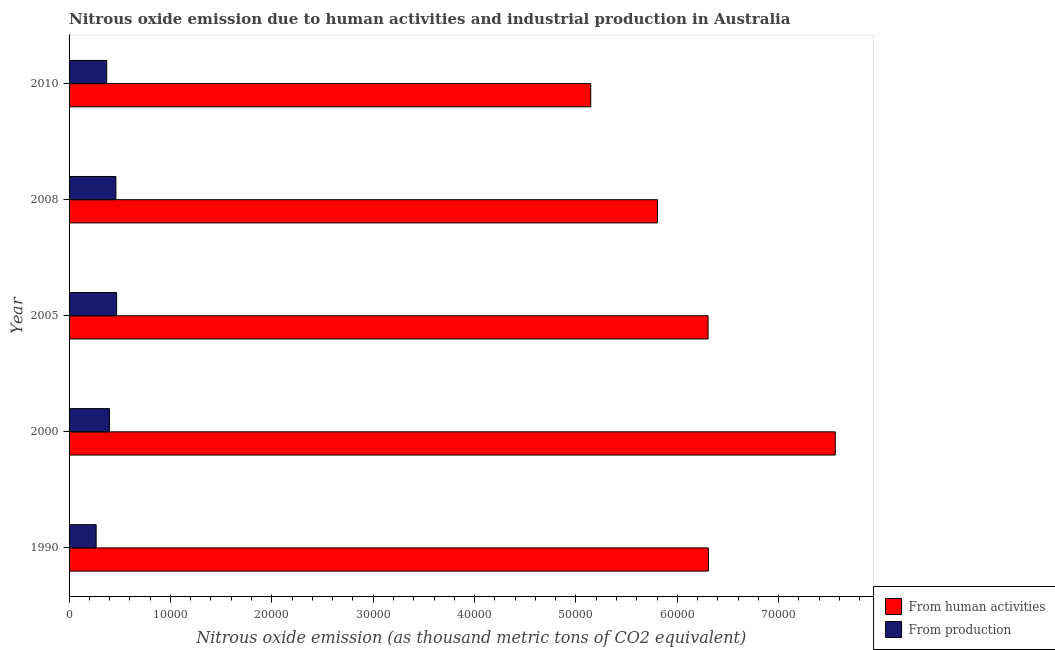How many groups of bars are there?
Offer a very short reply. 5. Are the number of bars on each tick of the Y-axis equal?
Provide a short and direct response. Yes. How many bars are there on the 4th tick from the top?
Make the answer very short. 2. What is the label of the 4th group of bars from the top?
Provide a short and direct response. 2000. In how many cases, is the number of bars for a given year not equal to the number of legend labels?
Your response must be concise. 0. What is the amount of emissions generated from industries in 2010?
Provide a succinct answer. 3714. Across all years, what is the maximum amount of emissions from human activities?
Offer a very short reply. 7.56e+04. Across all years, what is the minimum amount of emissions generated from industries?
Your response must be concise. 2671. In which year was the amount of emissions from human activities maximum?
Provide a succinct answer. 2000. What is the total amount of emissions from human activities in the graph?
Provide a succinct answer. 3.11e+05. What is the difference between the amount of emissions from human activities in 2000 and that in 2005?
Provide a short and direct response. 1.25e+04. What is the difference between the amount of emissions from human activities in 2000 and the amount of emissions generated from industries in 2008?
Your answer should be very brief. 7.10e+04. What is the average amount of emissions generated from industries per year?
Offer a very short reply. 3935.56. In the year 2008, what is the difference between the amount of emissions generated from industries and amount of emissions from human activities?
Provide a short and direct response. -5.34e+04. Is the difference between the amount of emissions generated from industries in 2000 and 2008 greater than the difference between the amount of emissions from human activities in 2000 and 2008?
Your answer should be very brief. No. What is the difference between the highest and the second highest amount of emissions from human activities?
Offer a very short reply. 1.25e+04. What is the difference between the highest and the lowest amount of emissions generated from industries?
Make the answer very short. 2019.1. Is the sum of the amount of emissions generated from industries in 1990 and 2005 greater than the maximum amount of emissions from human activities across all years?
Give a very brief answer. No. What does the 1st bar from the top in 2010 represents?
Ensure brevity in your answer.  From production. What does the 1st bar from the bottom in 2000 represents?
Your answer should be very brief. From human activities. How many bars are there?
Give a very brief answer. 10. What is the difference between two consecutive major ticks on the X-axis?
Ensure brevity in your answer.  10000. Where does the legend appear in the graph?
Give a very brief answer. Bottom right. How many legend labels are there?
Provide a succinct answer. 2. How are the legend labels stacked?
Offer a terse response. Vertical. What is the title of the graph?
Give a very brief answer. Nitrous oxide emission due to human activities and industrial production in Australia. What is the label or title of the X-axis?
Your answer should be compact. Nitrous oxide emission (as thousand metric tons of CO2 equivalent). What is the label or title of the Y-axis?
Offer a very short reply. Year. What is the Nitrous oxide emission (as thousand metric tons of CO2 equivalent) in From human activities in 1990?
Give a very brief answer. 6.31e+04. What is the Nitrous oxide emission (as thousand metric tons of CO2 equivalent) in From production in 1990?
Provide a short and direct response. 2671. What is the Nitrous oxide emission (as thousand metric tons of CO2 equivalent) in From human activities in 2000?
Your answer should be very brief. 7.56e+04. What is the Nitrous oxide emission (as thousand metric tons of CO2 equivalent) in From production in 2000?
Ensure brevity in your answer.  3981.7. What is the Nitrous oxide emission (as thousand metric tons of CO2 equivalent) in From human activities in 2005?
Give a very brief answer. 6.30e+04. What is the Nitrous oxide emission (as thousand metric tons of CO2 equivalent) of From production in 2005?
Offer a very short reply. 4690.1. What is the Nitrous oxide emission (as thousand metric tons of CO2 equivalent) in From human activities in 2008?
Provide a succinct answer. 5.80e+04. What is the Nitrous oxide emission (as thousand metric tons of CO2 equivalent) of From production in 2008?
Provide a short and direct response. 4621. What is the Nitrous oxide emission (as thousand metric tons of CO2 equivalent) of From human activities in 2010?
Your response must be concise. 5.15e+04. What is the Nitrous oxide emission (as thousand metric tons of CO2 equivalent) in From production in 2010?
Offer a very short reply. 3714. Across all years, what is the maximum Nitrous oxide emission (as thousand metric tons of CO2 equivalent) in From human activities?
Your response must be concise. 7.56e+04. Across all years, what is the maximum Nitrous oxide emission (as thousand metric tons of CO2 equivalent) of From production?
Your answer should be very brief. 4690.1. Across all years, what is the minimum Nitrous oxide emission (as thousand metric tons of CO2 equivalent) in From human activities?
Offer a very short reply. 5.15e+04. Across all years, what is the minimum Nitrous oxide emission (as thousand metric tons of CO2 equivalent) in From production?
Ensure brevity in your answer.  2671. What is the total Nitrous oxide emission (as thousand metric tons of CO2 equivalent) of From human activities in the graph?
Keep it short and to the point. 3.11e+05. What is the total Nitrous oxide emission (as thousand metric tons of CO2 equivalent) in From production in the graph?
Keep it short and to the point. 1.97e+04. What is the difference between the Nitrous oxide emission (as thousand metric tons of CO2 equivalent) of From human activities in 1990 and that in 2000?
Make the answer very short. -1.25e+04. What is the difference between the Nitrous oxide emission (as thousand metric tons of CO2 equivalent) of From production in 1990 and that in 2000?
Offer a very short reply. -1310.7. What is the difference between the Nitrous oxide emission (as thousand metric tons of CO2 equivalent) in From human activities in 1990 and that in 2005?
Provide a short and direct response. 29.4. What is the difference between the Nitrous oxide emission (as thousand metric tons of CO2 equivalent) of From production in 1990 and that in 2005?
Keep it short and to the point. -2019.1. What is the difference between the Nitrous oxide emission (as thousand metric tons of CO2 equivalent) of From human activities in 1990 and that in 2008?
Provide a succinct answer. 5020.4. What is the difference between the Nitrous oxide emission (as thousand metric tons of CO2 equivalent) of From production in 1990 and that in 2008?
Give a very brief answer. -1950. What is the difference between the Nitrous oxide emission (as thousand metric tons of CO2 equivalent) of From human activities in 1990 and that in 2010?
Offer a very short reply. 1.16e+04. What is the difference between the Nitrous oxide emission (as thousand metric tons of CO2 equivalent) of From production in 1990 and that in 2010?
Provide a short and direct response. -1043. What is the difference between the Nitrous oxide emission (as thousand metric tons of CO2 equivalent) in From human activities in 2000 and that in 2005?
Keep it short and to the point. 1.25e+04. What is the difference between the Nitrous oxide emission (as thousand metric tons of CO2 equivalent) in From production in 2000 and that in 2005?
Offer a very short reply. -708.4. What is the difference between the Nitrous oxide emission (as thousand metric tons of CO2 equivalent) of From human activities in 2000 and that in 2008?
Offer a very short reply. 1.75e+04. What is the difference between the Nitrous oxide emission (as thousand metric tons of CO2 equivalent) in From production in 2000 and that in 2008?
Your response must be concise. -639.3. What is the difference between the Nitrous oxide emission (as thousand metric tons of CO2 equivalent) in From human activities in 2000 and that in 2010?
Give a very brief answer. 2.41e+04. What is the difference between the Nitrous oxide emission (as thousand metric tons of CO2 equivalent) of From production in 2000 and that in 2010?
Make the answer very short. 267.7. What is the difference between the Nitrous oxide emission (as thousand metric tons of CO2 equivalent) in From human activities in 2005 and that in 2008?
Make the answer very short. 4991. What is the difference between the Nitrous oxide emission (as thousand metric tons of CO2 equivalent) in From production in 2005 and that in 2008?
Offer a terse response. 69.1. What is the difference between the Nitrous oxide emission (as thousand metric tons of CO2 equivalent) of From human activities in 2005 and that in 2010?
Keep it short and to the point. 1.16e+04. What is the difference between the Nitrous oxide emission (as thousand metric tons of CO2 equivalent) of From production in 2005 and that in 2010?
Your response must be concise. 976.1. What is the difference between the Nitrous oxide emission (as thousand metric tons of CO2 equivalent) in From human activities in 2008 and that in 2010?
Ensure brevity in your answer.  6584.9. What is the difference between the Nitrous oxide emission (as thousand metric tons of CO2 equivalent) of From production in 2008 and that in 2010?
Provide a short and direct response. 907. What is the difference between the Nitrous oxide emission (as thousand metric tons of CO2 equivalent) in From human activities in 1990 and the Nitrous oxide emission (as thousand metric tons of CO2 equivalent) in From production in 2000?
Your answer should be very brief. 5.91e+04. What is the difference between the Nitrous oxide emission (as thousand metric tons of CO2 equivalent) in From human activities in 1990 and the Nitrous oxide emission (as thousand metric tons of CO2 equivalent) in From production in 2005?
Your response must be concise. 5.84e+04. What is the difference between the Nitrous oxide emission (as thousand metric tons of CO2 equivalent) of From human activities in 1990 and the Nitrous oxide emission (as thousand metric tons of CO2 equivalent) of From production in 2008?
Offer a very short reply. 5.84e+04. What is the difference between the Nitrous oxide emission (as thousand metric tons of CO2 equivalent) of From human activities in 1990 and the Nitrous oxide emission (as thousand metric tons of CO2 equivalent) of From production in 2010?
Offer a very short reply. 5.94e+04. What is the difference between the Nitrous oxide emission (as thousand metric tons of CO2 equivalent) of From human activities in 2000 and the Nitrous oxide emission (as thousand metric tons of CO2 equivalent) of From production in 2005?
Keep it short and to the point. 7.09e+04. What is the difference between the Nitrous oxide emission (as thousand metric tons of CO2 equivalent) in From human activities in 2000 and the Nitrous oxide emission (as thousand metric tons of CO2 equivalent) in From production in 2008?
Keep it short and to the point. 7.10e+04. What is the difference between the Nitrous oxide emission (as thousand metric tons of CO2 equivalent) in From human activities in 2000 and the Nitrous oxide emission (as thousand metric tons of CO2 equivalent) in From production in 2010?
Keep it short and to the point. 7.19e+04. What is the difference between the Nitrous oxide emission (as thousand metric tons of CO2 equivalent) of From human activities in 2005 and the Nitrous oxide emission (as thousand metric tons of CO2 equivalent) of From production in 2008?
Offer a terse response. 5.84e+04. What is the difference between the Nitrous oxide emission (as thousand metric tons of CO2 equivalent) in From human activities in 2005 and the Nitrous oxide emission (as thousand metric tons of CO2 equivalent) in From production in 2010?
Your answer should be very brief. 5.93e+04. What is the difference between the Nitrous oxide emission (as thousand metric tons of CO2 equivalent) of From human activities in 2008 and the Nitrous oxide emission (as thousand metric tons of CO2 equivalent) of From production in 2010?
Your response must be concise. 5.43e+04. What is the average Nitrous oxide emission (as thousand metric tons of CO2 equivalent) of From human activities per year?
Your response must be concise. 6.22e+04. What is the average Nitrous oxide emission (as thousand metric tons of CO2 equivalent) in From production per year?
Your response must be concise. 3935.56. In the year 1990, what is the difference between the Nitrous oxide emission (as thousand metric tons of CO2 equivalent) of From human activities and Nitrous oxide emission (as thousand metric tons of CO2 equivalent) of From production?
Your answer should be compact. 6.04e+04. In the year 2000, what is the difference between the Nitrous oxide emission (as thousand metric tons of CO2 equivalent) of From human activities and Nitrous oxide emission (as thousand metric tons of CO2 equivalent) of From production?
Ensure brevity in your answer.  7.16e+04. In the year 2005, what is the difference between the Nitrous oxide emission (as thousand metric tons of CO2 equivalent) in From human activities and Nitrous oxide emission (as thousand metric tons of CO2 equivalent) in From production?
Your response must be concise. 5.83e+04. In the year 2008, what is the difference between the Nitrous oxide emission (as thousand metric tons of CO2 equivalent) in From human activities and Nitrous oxide emission (as thousand metric tons of CO2 equivalent) in From production?
Your response must be concise. 5.34e+04. In the year 2010, what is the difference between the Nitrous oxide emission (as thousand metric tons of CO2 equivalent) in From human activities and Nitrous oxide emission (as thousand metric tons of CO2 equivalent) in From production?
Offer a very short reply. 4.77e+04. What is the ratio of the Nitrous oxide emission (as thousand metric tons of CO2 equivalent) in From human activities in 1990 to that in 2000?
Your answer should be compact. 0.83. What is the ratio of the Nitrous oxide emission (as thousand metric tons of CO2 equivalent) of From production in 1990 to that in 2000?
Provide a succinct answer. 0.67. What is the ratio of the Nitrous oxide emission (as thousand metric tons of CO2 equivalent) of From human activities in 1990 to that in 2005?
Your answer should be compact. 1. What is the ratio of the Nitrous oxide emission (as thousand metric tons of CO2 equivalent) of From production in 1990 to that in 2005?
Give a very brief answer. 0.57. What is the ratio of the Nitrous oxide emission (as thousand metric tons of CO2 equivalent) of From human activities in 1990 to that in 2008?
Keep it short and to the point. 1.09. What is the ratio of the Nitrous oxide emission (as thousand metric tons of CO2 equivalent) in From production in 1990 to that in 2008?
Provide a succinct answer. 0.58. What is the ratio of the Nitrous oxide emission (as thousand metric tons of CO2 equivalent) in From human activities in 1990 to that in 2010?
Give a very brief answer. 1.23. What is the ratio of the Nitrous oxide emission (as thousand metric tons of CO2 equivalent) of From production in 1990 to that in 2010?
Provide a succinct answer. 0.72. What is the ratio of the Nitrous oxide emission (as thousand metric tons of CO2 equivalent) of From human activities in 2000 to that in 2005?
Your answer should be very brief. 1.2. What is the ratio of the Nitrous oxide emission (as thousand metric tons of CO2 equivalent) in From production in 2000 to that in 2005?
Your answer should be compact. 0.85. What is the ratio of the Nitrous oxide emission (as thousand metric tons of CO2 equivalent) in From human activities in 2000 to that in 2008?
Provide a succinct answer. 1.3. What is the ratio of the Nitrous oxide emission (as thousand metric tons of CO2 equivalent) of From production in 2000 to that in 2008?
Your answer should be compact. 0.86. What is the ratio of the Nitrous oxide emission (as thousand metric tons of CO2 equivalent) in From human activities in 2000 to that in 2010?
Keep it short and to the point. 1.47. What is the ratio of the Nitrous oxide emission (as thousand metric tons of CO2 equivalent) of From production in 2000 to that in 2010?
Your response must be concise. 1.07. What is the ratio of the Nitrous oxide emission (as thousand metric tons of CO2 equivalent) of From human activities in 2005 to that in 2008?
Your answer should be very brief. 1.09. What is the ratio of the Nitrous oxide emission (as thousand metric tons of CO2 equivalent) of From human activities in 2005 to that in 2010?
Provide a short and direct response. 1.22. What is the ratio of the Nitrous oxide emission (as thousand metric tons of CO2 equivalent) in From production in 2005 to that in 2010?
Your answer should be very brief. 1.26. What is the ratio of the Nitrous oxide emission (as thousand metric tons of CO2 equivalent) in From human activities in 2008 to that in 2010?
Ensure brevity in your answer.  1.13. What is the ratio of the Nitrous oxide emission (as thousand metric tons of CO2 equivalent) of From production in 2008 to that in 2010?
Your answer should be compact. 1.24. What is the difference between the highest and the second highest Nitrous oxide emission (as thousand metric tons of CO2 equivalent) in From human activities?
Make the answer very short. 1.25e+04. What is the difference between the highest and the second highest Nitrous oxide emission (as thousand metric tons of CO2 equivalent) in From production?
Offer a very short reply. 69.1. What is the difference between the highest and the lowest Nitrous oxide emission (as thousand metric tons of CO2 equivalent) of From human activities?
Give a very brief answer. 2.41e+04. What is the difference between the highest and the lowest Nitrous oxide emission (as thousand metric tons of CO2 equivalent) of From production?
Make the answer very short. 2019.1. 